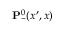Convert formula to latex. <formula><loc_0><loc_0><loc_500><loc_500>{ P } _ { - } ^ { 0 } ( x ^ { \prime } , x )</formula> 